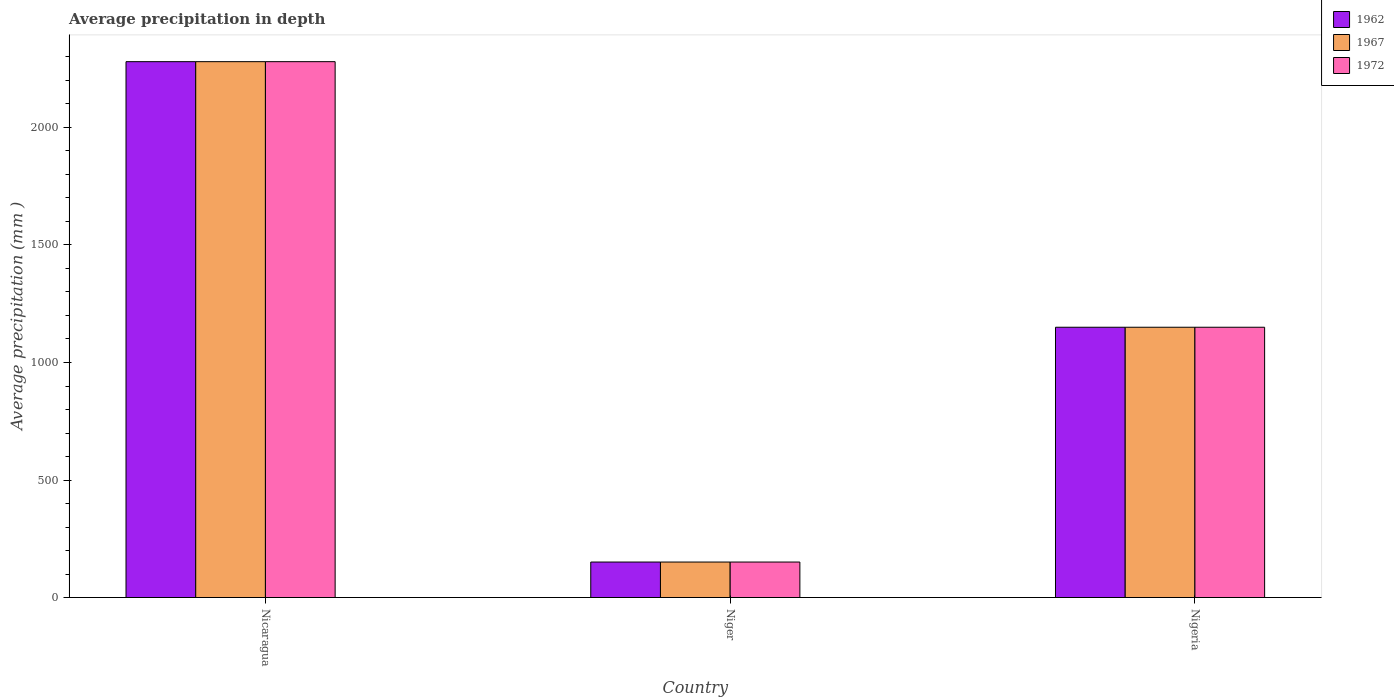How many groups of bars are there?
Make the answer very short. 3. Are the number of bars per tick equal to the number of legend labels?
Ensure brevity in your answer.  Yes. How many bars are there on the 1st tick from the left?
Offer a very short reply. 3. How many bars are there on the 2nd tick from the right?
Your answer should be compact. 3. What is the label of the 3rd group of bars from the left?
Keep it short and to the point. Nigeria. What is the average precipitation in 1972 in Niger?
Give a very brief answer. 151. Across all countries, what is the maximum average precipitation in 1972?
Keep it short and to the point. 2280. Across all countries, what is the minimum average precipitation in 1967?
Provide a succinct answer. 151. In which country was the average precipitation in 1962 maximum?
Provide a short and direct response. Nicaragua. In which country was the average precipitation in 1972 minimum?
Provide a short and direct response. Niger. What is the total average precipitation in 1967 in the graph?
Your response must be concise. 3581. What is the difference between the average precipitation in 1967 in Niger and that in Nigeria?
Your answer should be compact. -999. What is the difference between the average precipitation in 1962 in Niger and the average precipitation in 1972 in Nicaragua?
Keep it short and to the point. -2129. What is the average average precipitation in 1972 per country?
Your answer should be compact. 1193.67. What is the difference between the average precipitation of/in 1967 and average precipitation of/in 1972 in Niger?
Your answer should be compact. 0. In how many countries, is the average precipitation in 1967 greater than 600 mm?
Give a very brief answer. 2. What is the ratio of the average precipitation in 1967 in Niger to that in Nigeria?
Offer a terse response. 0.13. What is the difference between the highest and the second highest average precipitation in 1972?
Offer a terse response. 1130. What is the difference between the highest and the lowest average precipitation in 1967?
Your answer should be very brief. 2129. Is the sum of the average precipitation in 1967 in Niger and Nigeria greater than the maximum average precipitation in 1972 across all countries?
Give a very brief answer. No. Is it the case that in every country, the sum of the average precipitation in 1967 and average precipitation in 1972 is greater than the average precipitation in 1962?
Provide a short and direct response. Yes. How many bars are there?
Make the answer very short. 9. Does the graph contain any zero values?
Give a very brief answer. No. Does the graph contain grids?
Offer a terse response. No. How many legend labels are there?
Your response must be concise. 3. How are the legend labels stacked?
Give a very brief answer. Vertical. What is the title of the graph?
Offer a very short reply. Average precipitation in depth. Does "2003" appear as one of the legend labels in the graph?
Keep it short and to the point. No. What is the label or title of the Y-axis?
Offer a terse response. Average precipitation (mm ). What is the Average precipitation (mm ) of 1962 in Nicaragua?
Provide a short and direct response. 2280. What is the Average precipitation (mm ) in 1967 in Nicaragua?
Your answer should be compact. 2280. What is the Average precipitation (mm ) of 1972 in Nicaragua?
Ensure brevity in your answer.  2280. What is the Average precipitation (mm ) of 1962 in Niger?
Keep it short and to the point. 151. What is the Average precipitation (mm ) in 1967 in Niger?
Provide a succinct answer. 151. What is the Average precipitation (mm ) in 1972 in Niger?
Your response must be concise. 151. What is the Average precipitation (mm ) in 1962 in Nigeria?
Ensure brevity in your answer.  1150. What is the Average precipitation (mm ) in 1967 in Nigeria?
Your answer should be compact. 1150. What is the Average precipitation (mm ) of 1972 in Nigeria?
Make the answer very short. 1150. Across all countries, what is the maximum Average precipitation (mm ) in 1962?
Keep it short and to the point. 2280. Across all countries, what is the maximum Average precipitation (mm ) of 1967?
Ensure brevity in your answer.  2280. Across all countries, what is the maximum Average precipitation (mm ) of 1972?
Give a very brief answer. 2280. Across all countries, what is the minimum Average precipitation (mm ) in 1962?
Offer a very short reply. 151. Across all countries, what is the minimum Average precipitation (mm ) of 1967?
Provide a short and direct response. 151. Across all countries, what is the minimum Average precipitation (mm ) of 1972?
Your answer should be very brief. 151. What is the total Average precipitation (mm ) of 1962 in the graph?
Provide a succinct answer. 3581. What is the total Average precipitation (mm ) of 1967 in the graph?
Ensure brevity in your answer.  3581. What is the total Average precipitation (mm ) in 1972 in the graph?
Offer a very short reply. 3581. What is the difference between the Average precipitation (mm ) in 1962 in Nicaragua and that in Niger?
Keep it short and to the point. 2129. What is the difference between the Average precipitation (mm ) of 1967 in Nicaragua and that in Niger?
Give a very brief answer. 2129. What is the difference between the Average precipitation (mm ) in 1972 in Nicaragua and that in Niger?
Your answer should be compact. 2129. What is the difference between the Average precipitation (mm ) in 1962 in Nicaragua and that in Nigeria?
Give a very brief answer. 1130. What is the difference between the Average precipitation (mm ) in 1967 in Nicaragua and that in Nigeria?
Your response must be concise. 1130. What is the difference between the Average precipitation (mm ) of 1972 in Nicaragua and that in Nigeria?
Ensure brevity in your answer.  1130. What is the difference between the Average precipitation (mm ) in 1962 in Niger and that in Nigeria?
Your answer should be compact. -999. What is the difference between the Average precipitation (mm ) of 1967 in Niger and that in Nigeria?
Provide a short and direct response. -999. What is the difference between the Average precipitation (mm ) in 1972 in Niger and that in Nigeria?
Give a very brief answer. -999. What is the difference between the Average precipitation (mm ) in 1962 in Nicaragua and the Average precipitation (mm ) in 1967 in Niger?
Ensure brevity in your answer.  2129. What is the difference between the Average precipitation (mm ) in 1962 in Nicaragua and the Average precipitation (mm ) in 1972 in Niger?
Provide a short and direct response. 2129. What is the difference between the Average precipitation (mm ) in 1967 in Nicaragua and the Average precipitation (mm ) in 1972 in Niger?
Provide a succinct answer. 2129. What is the difference between the Average precipitation (mm ) of 1962 in Nicaragua and the Average precipitation (mm ) of 1967 in Nigeria?
Your answer should be very brief. 1130. What is the difference between the Average precipitation (mm ) of 1962 in Nicaragua and the Average precipitation (mm ) of 1972 in Nigeria?
Provide a short and direct response. 1130. What is the difference between the Average precipitation (mm ) of 1967 in Nicaragua and the Average precipitation (mm ) of 1972 in Nigeria?
Your answer should be very brief. 1130. What is the difference between the Average precipitation (mm ) of 1962 in Niger and the Average precipitation (mm ) of 1967 in Nigeria?
Your response must be concise. -999. What is the difference between the Average precipitation (mm ) of 1962 in Niger and the Average precipitation (mm ) of 1972 in Nigeria?
Offer a very short reply. -999. What is the difference between the Average precipitation (mm ) in 1967 in Niger and the Average precipitation (mm ) in 1972 in Nigeria?
Ensure brevity in your answer.  -999. What is the average Average precipitation (mm ) in 1962 per country?
Provide a succinct answer. 1193.67. What is the average Average precipitation (mm ) of 1967 per country?
Offer a very short reply. 1193.67. What is the average Average precipitation (mm ) in 1972 per country?
Offer a terse response. 1193.67. What is the difference between the Average precipitation (mm ) of 1962 and Average precipitation (mm ) of 1967 in Nicaragua?
Keep it short and to the point. 0. What is the difference between the Average precipitation (mm ) of 1962 and Average precipitation (mm ) of 1972 in Niger?
Give a very brief answer. 0. What is the difference between the Average precipitation (mm ) in 1962 and Average precipitation (mm ) in 1972 in Nigeria?
Offer a very short reply. 0. What is the difference between the Average precipitation (mm ) of 1967 and Average precipitation (mm ) of 1972 in Nigeria?
Your answer should be compact. 0. What is the ratio of the Average precipitation (mm ) of 1962 in Nicaragua to that in Niger?
Your answer should be very brief. 15.1. What is the ratio of the Average precipitation (mm ) of 1967 in Nicaragua to that in Niger?
Your answer should be compact. 15.1. What is the ratio of the Average precipitation (mm ) of 1972 in Nicaragua to that in Niger?
Ensure brevity in your answer.  15.1. What is the ratio of the Average precipitation (mm ) of 1962 in Nicaragua to that in Nigeria?
Provide a succinct answer. 1.98. What is the ratio of the Average precipitation (mm ) of 1967 in Nicaragua to that in Nigeria?
Provide a short and direct response. 1.98. What is the ratio of the Average precipitation (mm ) of 1972 in Nicaragua to that in Nigeria?
Your answer should be very brief. 1.98. What is the ratio of the Average precipitation (mm ) in 1962 in Niger to that in Nigeria?
Offer a very short reply. 0.13. What is the ratio of the Average precipitation (mm ) in 1967 in Niger to that in Nigeria?
Offer a very short reply. 0.13. What is the ratio of the Average precipitation (mm ) of 1972 in Niger to that in Nigeria?
Your answer should be compact. 0.13. What is the difference between the highest and the second highest Average precipitation (mm ) in 1962?
Offer a terse response. 1130. What is the difference between the highest and the second highest Average precipitation (mm ) of 1967?
Your answer should be very brief. 1130. What is the difference between the highest and the second highest Average precipitation (mm ) in 1972?
Your answer should be very brief. 1130. What is the difference between the highest and the lowest Average precipitation (mm ) in 1962?
Make the answer very short. 2129. What is the difference between the highest and the lowest Average precipitation (mm ) of 1967?
Make the answer very short. 2129. What is the difference between the highest and the lowest Average precipitation (mm ) in 1972?
Your answer should be very brief. 2129. 